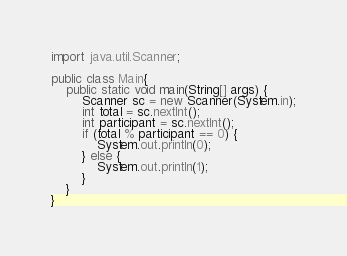<code> <loc_0><loc_0><loc_500><loc_500><_Java_>import java.util.Scanner;

public class Main{
	public static void main(String[] args) {
		Scanner sc = new Scanner(System.in);
		int total = sc.nextInt();
		int participant = sc.nextInt();
		if (total % participant == 0) {
			System.out.println(0);
		} else {
			System.out.println(1);
		}
	}
}
</code> 